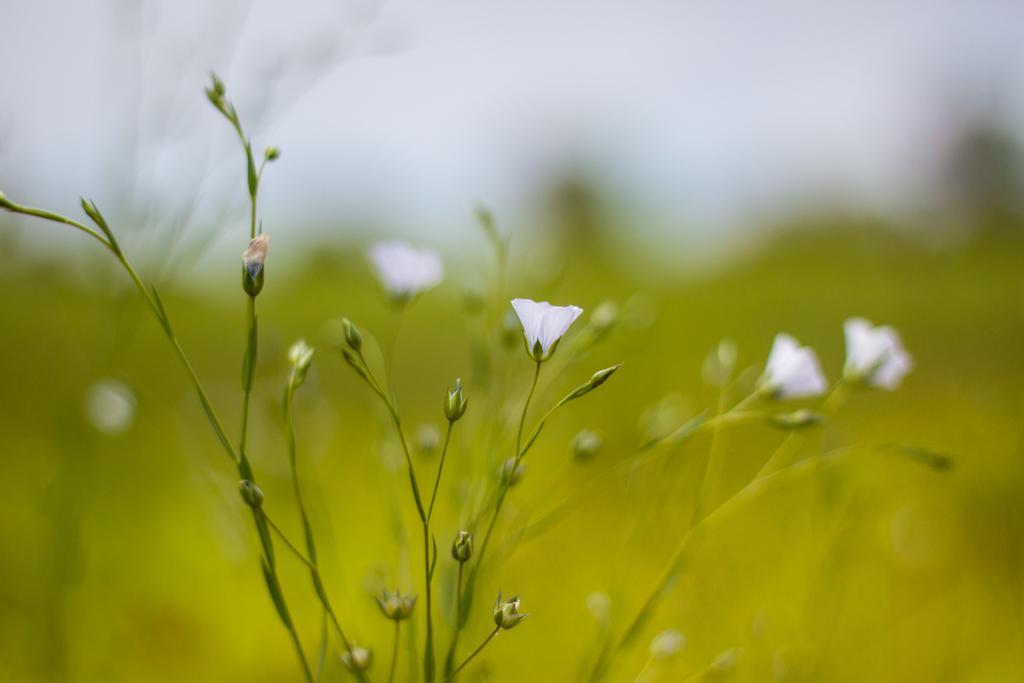Please provide a concise description of this image. In the front of the image there are flower plants. In the background of the image it is blurry. 